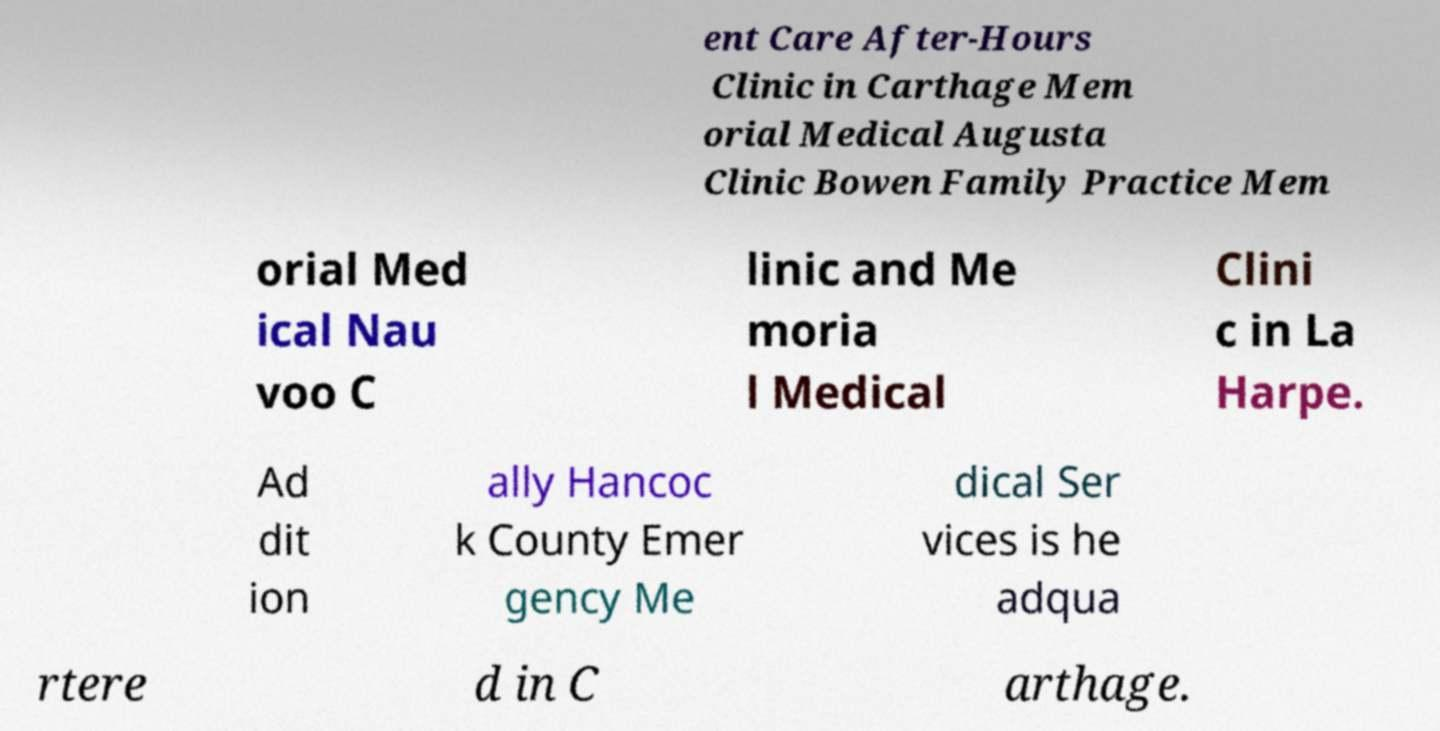Can you accurately transcribe the text from the provided image for me? ent Care After-Hours Clinic in Carthage Mem orial Medical Augusta Clinic Bowen Family Practice Mem orial Med ical Nau voo C linic and Me moria l Medical Clini c in La Harpe. Ad dit ion ally Hancoc k County Emer gency Me dical Ser vices is he adqua rtere d in C arthage. 